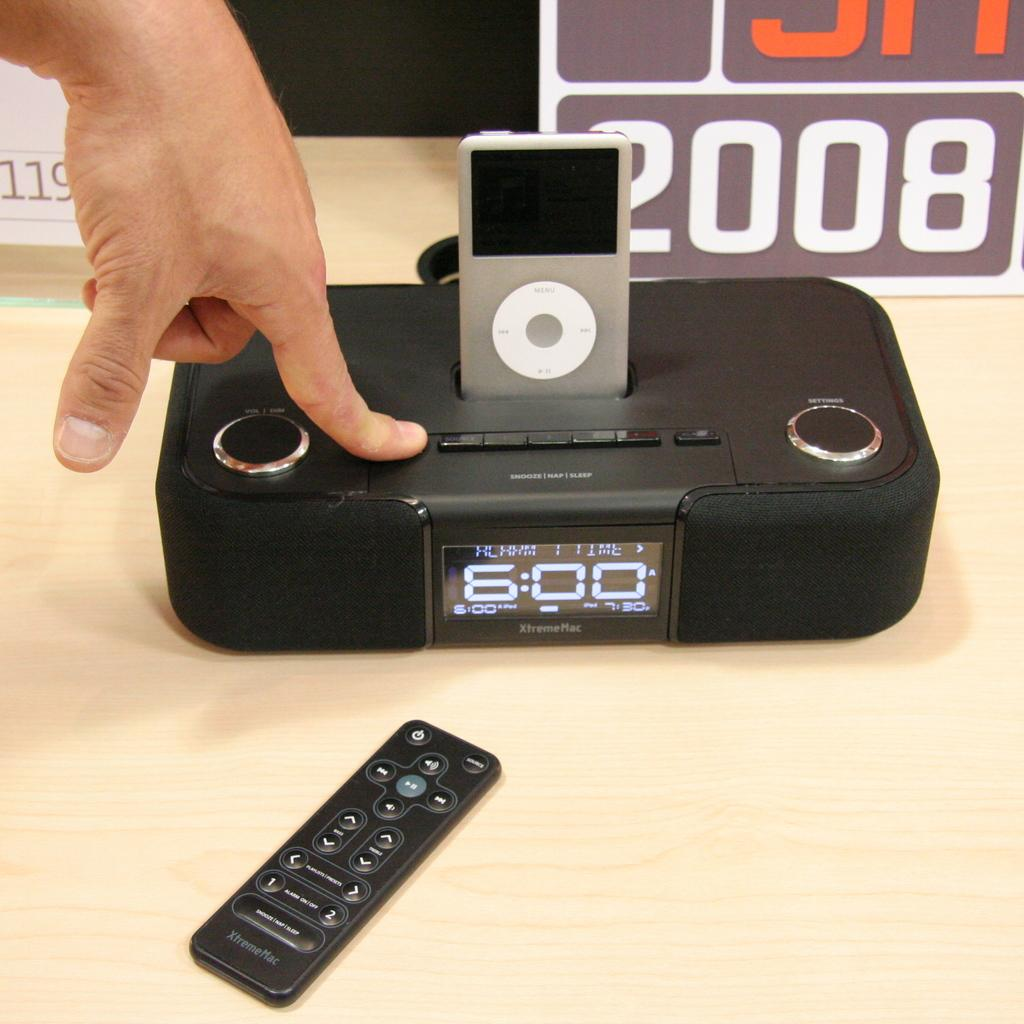<image>
Give a short and clear explanation of the subsequent image. A person is pressing a button on an alarm clock that says 6:00 and has an iPhone dock. 